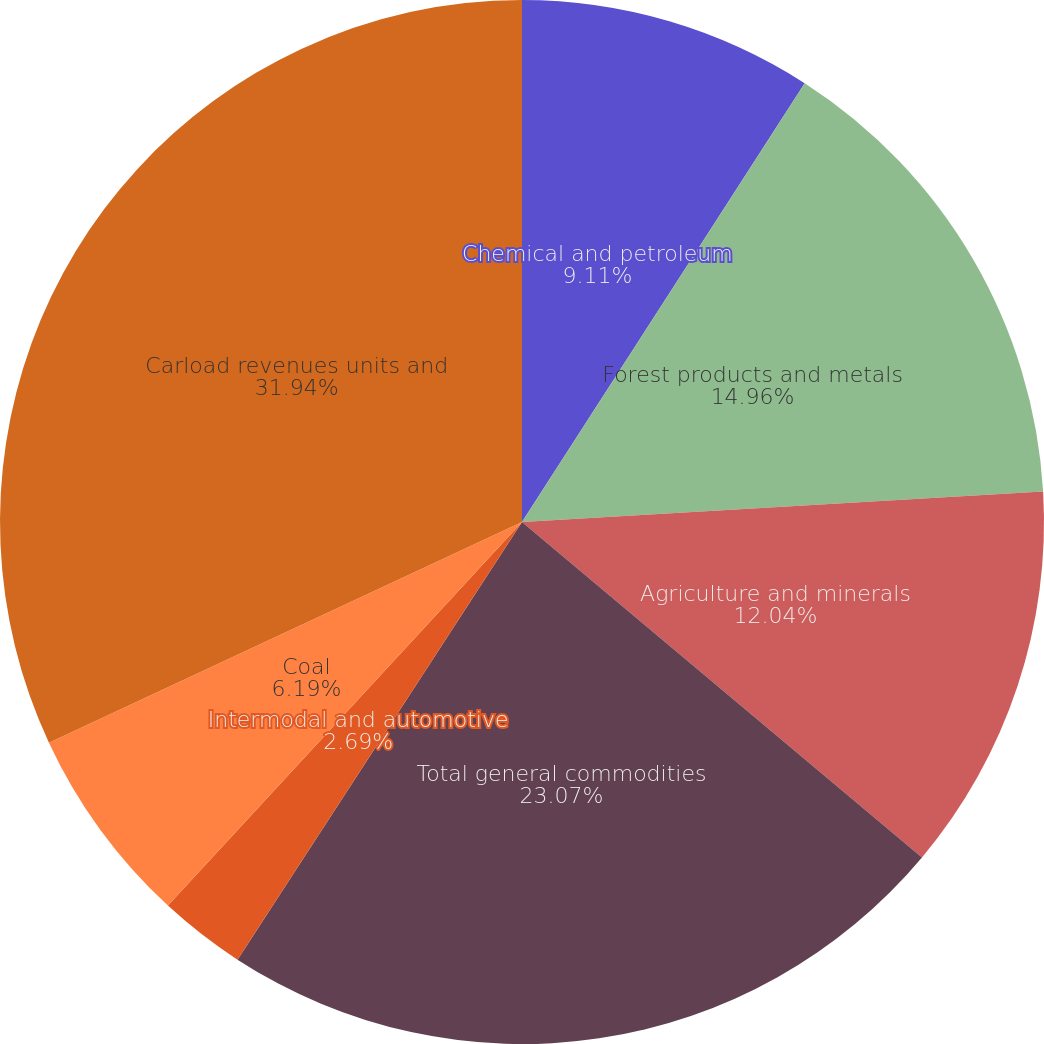Convert chart to OTSL. <chart><loc_0><loc_0><loc_500><loc_500><pie_chart><fcel>Chemical and petroleum<fcel>Forest products and metals<fcel>Agriculture and minerals<fcel>Total general commodities<fcel>Intermodal and automotive<fcel>Coal<fcel>Carload revenues units and<nl><fcel>9.11%<fcel>14.96%<fcel>12.04%<fcel>23.07%<fcel>2.69%<fcel>6.19%<fcel>31.95%<nl></chart> 